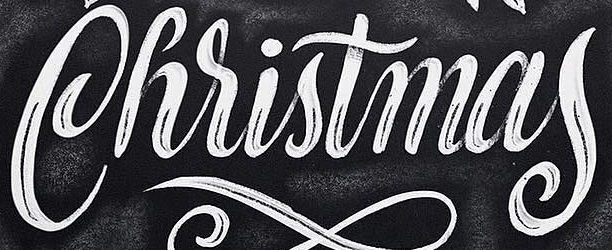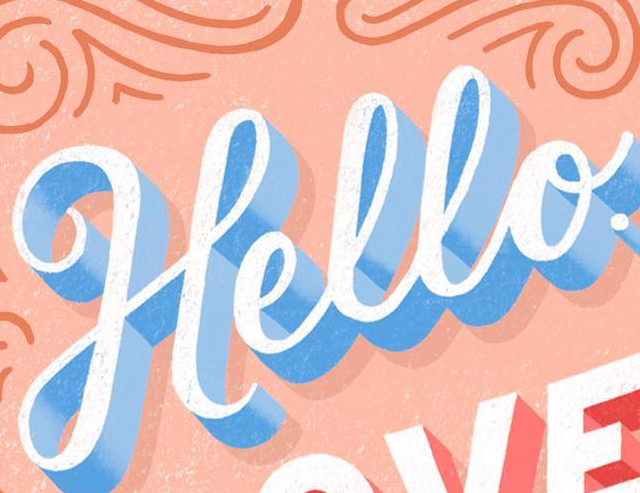What text appears in these images from left to right, separated by a semicolon? Christmas; Hello 